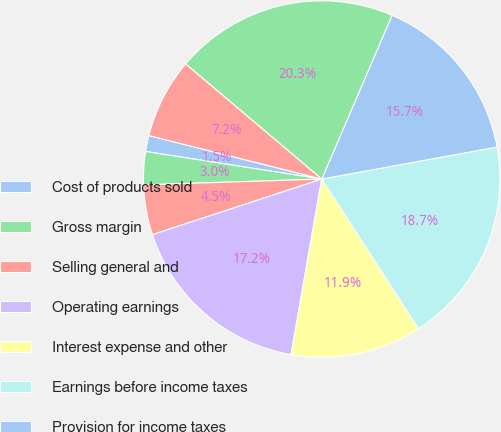Convert chart to OTSL. <chart><loc_0><loc_0><loc_500><loc_500><pie_chart><fcel>Cost of products sold<fcel>Gross margin<fcel>Selling general and<fcel>Operating earnings<fcel>Interest expense and other<fcel>Earnings before income taxes<fcel>Provision for income taxes<fcel>Earnings from continuing<fcel>Net diluted earnings per<nl><fcel>1.45%<fcel>2.99%<fcel>4.53%<fcel>17.2%<fcel>11.89%<fcel>18.74%<fcel>15.67%<fcel>20.28%<fcel>7.25%<nl></chart> 